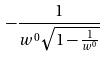Convert formula to latex. <formula><loc_0><loc_0><loc_500><loc_500>- \frac { 1 } { w ^ { 0 } \sqrt { 1 - \frac { 1 } { w ^ { 0 } } } }</formula> 